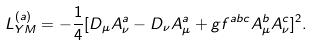<formula> <loc_0><loc_0><loc_500><loc_500>L _ { Y M } ^ { ( a ) } = - \frac { 1 } { 4 } [ D _ { \mu } A _ { \nu } ^ { a } - D _ { \nu } A _ { \mu } ^ { a } + g f ^ { a b c } A _ { \mu } ^ { b } A _ { \nu } ^ { c } ] ^ { 2 } .</formula> 